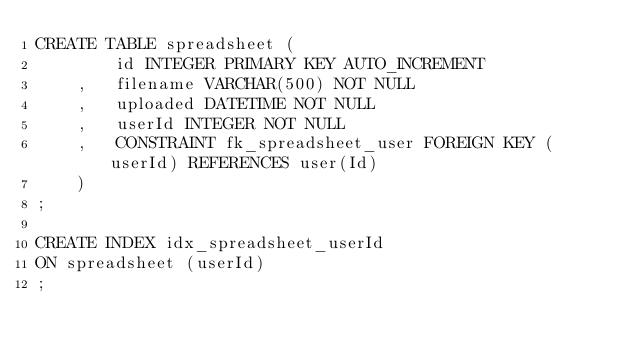Convert code to text. <code><loc_0><loc_0><loc_500><loc_500><_SQL_>CREATE TABLE spreadsheet (
        id INTEGER PRIMARY KEY AUTO_INCREMENT
    ,   filename VARCHAR(500) NOT NULL
    ,   uploaded DATETIME NOT NULL
    ,   userId INTEGER NOT NULL
    ,   CONSTRAINT fk_spreadsheet_user FOREIGN KEY (userId) REFERENCES user(Id)
    )
;

CREATE INDEX idx_spreadsheet_userId
ON spreadsheet (userId)
;
</code> 